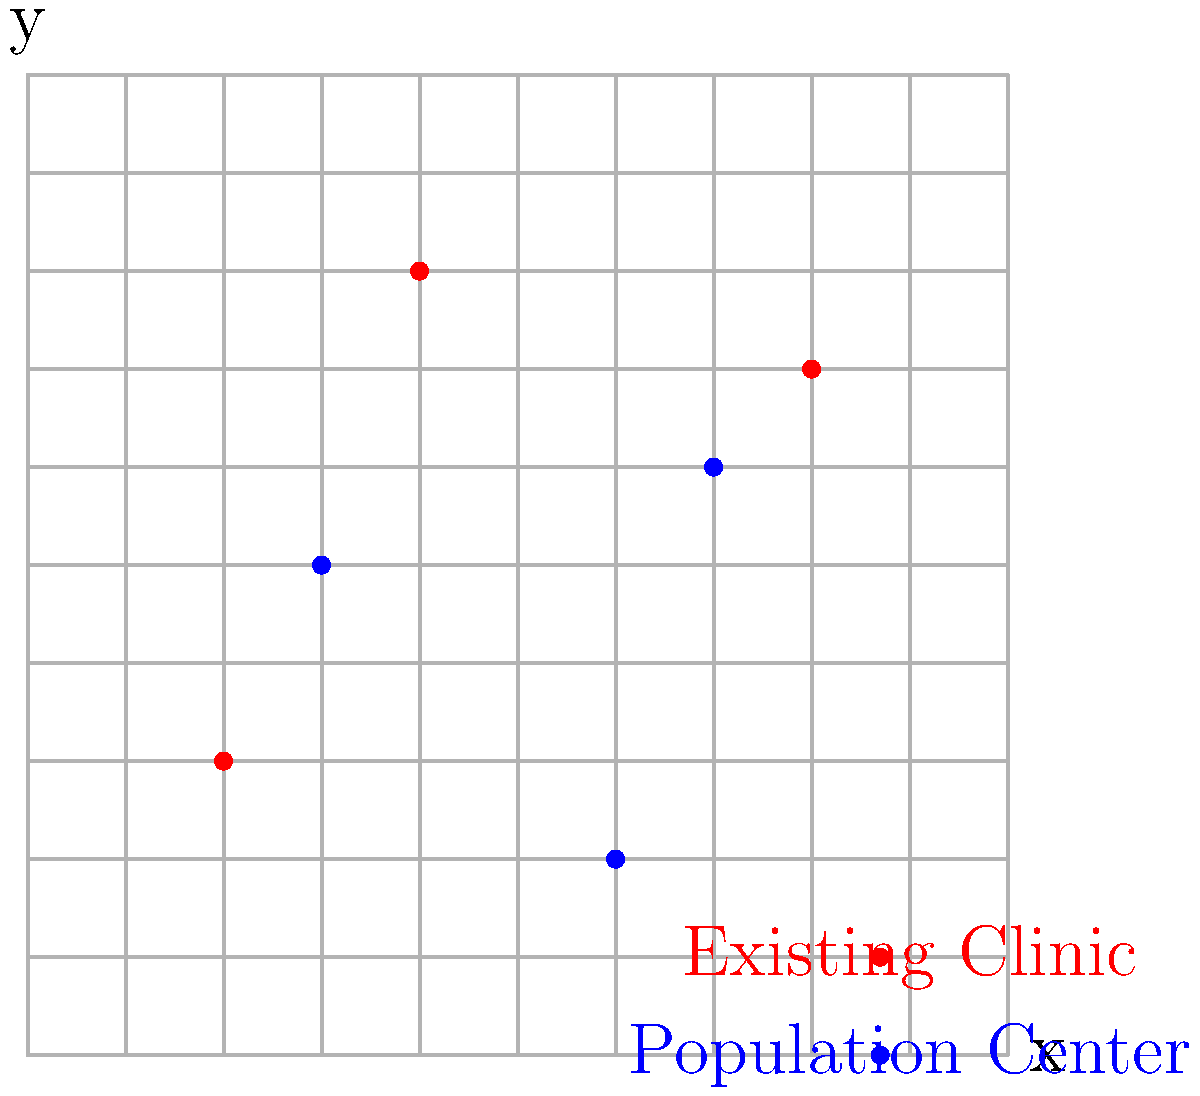Given the coordinate grid representing our community, where existing mobile health clinics are marked in red and major population centers are marked in blue, what are the coordinates of the optimal location for a new mobile health clinic that would minimize the average distance to all population centers while maintaining a minimum distance of 3 units from existing clinics? To determine the optimal location for the new mobile health clinic, we need to follow these steps:

1. Identify the coordinates of existing clinics:
   - Clinic 1: $(2,3)$
   - Clinic 2: $(8,7)$
   - Clinic 3: $(4,8)$

2. Identify the coordinates of population centers:
   - Center 1: $(3,5)$
   - Center 2: $(6,2)$
   - Center 3: $(7,6)$

3. Calculate the centroid of the population centers to minimize average distance:
   $x_{centroid} = \frac{3+6+7}{3} = \frac{16}{3} \approx 5.33$
   $y_{centroid} = \frac{5+2+6}{3} = \frac{13}{3} \approx 4.33$

4. Check if the centroid is at least 3 units away from existing clinics:
   - Distance to Clinic 1: $\sqrt{(5.33-2)^2 + (4.33-3)^2} \approx 3.54$
   - Distance to Clinic 2: $\sqrt{(5.33-8)^2 + (4.33-7)^2} \approx 3.92$
   - Distance to Clinic 3: $\sqrt{(5.33-4)^2 + (4.33-8)^2} \approx 3.83$

5. Since the centroid satisfies the minimum distance requirement, we can round the coordinates to the nearest whole numbers:
   $x = 5$, $y = 4$

Therefore, the optimal location for the new mobile health clinic is at coordinates $(5,4)$.
Answer: $(5,4)$ 